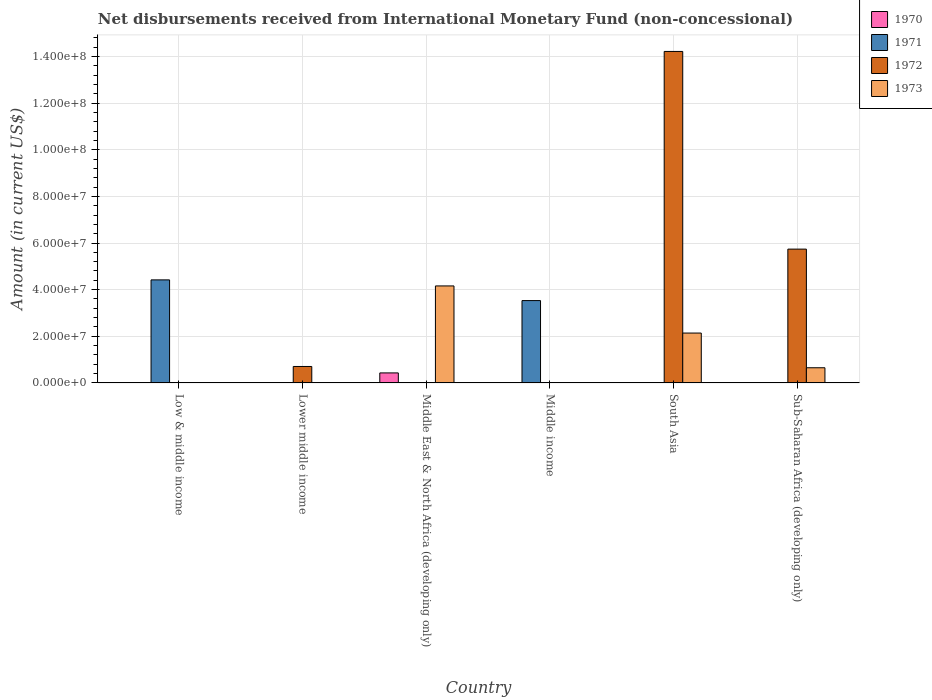Are the number of bars per tick equal to the number of legend labels?
Provide a short and direct response. No. What is the label of the 6th group of bars from the left?
Give a very brief answer. Sub-Saharan Africa (developing only). What is the amount of disbursements received from International Monetary Fund in 1971 in Lower middle income?
Provide a succinct answer. 0. Across all countries, what is the maximum amount of disbursements received from International Monetary Fund in 1973?
Offer a very short reply. 4.16e+07. What is the total amount of disbursements received from International Monetary Fund in 1970 in the graph?
Give a very brief answer. 4.30e+06. What is the difference between the amount of disbursements received from International Monetary Fund in 1971 in Low & middle income and that in Middle income?
Keep it short and to the point. 8.88e+06. What is the average amount of disbursements received from International Monetary Fund in 1970 per country?
Ensure brevity in your answer.  7.17e+05. What is the difference between the amount of disbursements received from International Monetary Fund of/in 1972 and amount of disbursements received from International Monetary Fund of/in 1973 in South Asia?
Your answer should be compact. 1.21e+08. What is the ratio of the amount of disbursements received from International Monetary Fund in 1971 in Low & middle income to that in Middle income?
Your response must be concise. 1.25. Is the amount of disbursements received from International Monetary Fund in 1973 in South Asia less than that in Sub-Saharan Africa (developing only)?
Offer a terse response. No. Is the difference between the amount of disbursements received from International Monetary Fund in 1972 in South Asia and Sub-Saharan Africa (developing only) greater than the difference between the amount of disbursements received from International Monetary Fund in 1973 in South Asia and Sub-Saharan Africa (developing only)?
Your response must be concise. Yes. What is the difference between the highest and the second highest amount of disbursements received from International Monetary Fund in 1973?
Ensure brevity in your answer.  3.51e+07. What is the difference between the highest and the lowest amount of disbursements received from International Monetary Fund in 1972?
Your response must be concise. 1.42e+08. In how many countries, is the amount of disbursements received from International Monetary Fund in 1971 greater than the average amount of disbursements received from International Monetary Fund in 1971 taken over all countries?
Ensure brevity in your answer.  2. Is it the case that in every country, the sum of the amount of disbursements received from International Monetary Fund in 1973 and amount of disbursements received from International Monetary Fund in 1970 is greater than the amount of disbursements received from International Monetary Fund in 1971?
Provide a succinct answer. No. How many bars are there?
Give a very brief answer. 9. Are all the bars in the graph horizontal?
Make the answer very short. No. What is the difference between two consecutive major ticks on the Y-axis?
Your answer should be compact. 2.00e+07. Does the graph contain any zero values?
Your response must be concise. Yes. Does the graph contain grids?
Provide a short and direct response. Yes. Where does the legend appear in the graph?
Your answer should be very brief. Top right. How many legend labels are there?
Your response must be concise. 4. How are the legend labels stacked?
Keep it short and to the point. Vertical. What is the title of the graph?
Offer a very short reply. Net disbursements received from International Monetary Fund (non-concessional). Does "1983" appear as one of the legend labels in the graph?
Keep it short and to the point. No. What is the Amount (in current US$) in 1971 in Low & middle income?
Your answer should be very brief. 4.42e+07. What is the Amount (in current US$) in 1972 in Low & middle income?
Your answer should be very brief. 0. What is the Amount (in current US$) of 1973 in Low & middle income?
Your response must be concise. 0. What is the Amount (in current US$) of 1970 in Lower middle income?
Ensure brevity in your answer.  0. What is the Amount (in current US$) of 1971 in Lower middle income?
Provide a short and direct response. 0. What is the Amount (in current US$) of 1972 in Lower middle income?
Your response must be concise. 7.06e+06. What is the Amount (in current US$) in 1973 in Lower middle income?
Your answer should be compact. 0. What is the Amount (in current US$) in 1970 in Middle East & North Africa (developing only)?
Offer a terse response. 4.30e+06. What is the Amount (in current US$) in 1973 in Middle East & North Africa (developing only)?
Your response must be concise. 4.16e+07. What is the Amount (in current US$) of 1970 in Middle income?
Offer a very short reply. 0. What is the Amount (in current US$) of 1971 in Middle income?
Your answer should be very brief. 3.53e+07. What is the Amount (in current US$) in 1972 in Middle income?
Make the answer very short. 0. What is the Amount (in current US$) of 1970 in South Asia?
Keep it short and to the point. 0. What is the Amount (in current US$) in 1971 in South Asia?
Provide a succinct answer. 0. What is the Amount (in current US$) in 1972 in South Asia?
Offer a terse response. 1.42e+08. What is the Amount (in current US$) in 1973 in South Asia?
Keep it short and to the point. 2.14e+07. What is the Amount (in current US$) of 1971 in Sub-Saharan Africa (developing only)?
Your response must be concise. 0. What is the Amount (in current US$) of 1972 in Sub-Saharan Africa (developing only)?
Make the answer very short. 5.74e+07. What is the Amount (in current US$) in 1973 in Sub-Saharan Africa (developing only)?
Ensure brevity in your answer.  6.51e+06. Across all countries, what is the maximum Amount (in current US$) of 1970?
Provide a succinct answer. 4.30e+06. Across all countries, what is the maximum Amount (in current US$) of 1971?
Provide a short and direct response. 4.42e+07. Across all countries, what is the maximum Amount (in current US$) in 1972?
Keep it short and to the point. 1.42e+08. Across all countries, what is the maximum Amount (in current US$) of 1973?
Keep it short and to the point. 4.16e+07. Across all countries, what is the minimum Amount (in current US$) in 1970?
Give a very brief answer. 0. Across all countries, what is the minimum Amount (in current US$) in 1971?
Offer a very short reply. 0. Across all countries, what is the minimum Amount (in current US$) in 1973?
Give a very brief answer. 0. What is the total Amount (in current US$) in 1970 in the graph?
Your answer should be compact. 4.30e+06. What is the total Amount (in current US$) in 1971 in the graph?
Give a very brief answer. 7.95e+07. What is the total Amount (in current US$) of 1972 in the graph?
Ensure brevity in your answer.  2.07e+08. What is the total Amount (in current US$) in 1973 in the graph?
Offer a terse response. 6.95e+07. What is the difference between the Amount (in current US$) in 1971 in Low & middle income and that in Middle income?
Your response must be concise. 8.88e+06. What is the difference between the Amount (in current US$) in 1972 in Lower middle income and that in South Asia?
Give a very brief answer. -1.35e+08. What is the difference between the Amount (in current US$) in 1972 in Lower middle income and that in Sub-Saharan Africa (developing only)?
Provide a succinct answer. -5.03e+07. What is the difference between the Amount (in current US$) of 1973 in Middle East & North Africa (developing only) and that in South Asia?
Provide a short and direct response. 2.02e+07. What is the difference between the Amount (in current US$) in 1973 in Middle East & North Africa (developing only) and that in Sub-Saharan Africa (developing only)?
Keep it short and to the point. 3.51e+07. What is the difference between the Amount (in current US$) in 1972 in South Asia and that in Sub-Saharan Africa (developing only)?
Ensure brevity in your answer.  8.48e+07. What is the difference between the Amount (in current US$) of 1973 in South Asia and that in Sub-Saharan Africa (developing only)?
Your answer should be very brief. 1.49e+07. What is the difference between the Amount (in current US$) in 1971 in Low & middle income and the Amount (in current US$) in 1972 in Lower middle income?
Offer a very short reply. 3.71e+07. What is the difference between the Amount (in current US$) in 1971 in Low & middle income and the Amount (in current US$) in 1973 in Middle East & North Africa (developing only)?
Your response must be concise. 2.60e+06. What is the difference between the Amount (in current US$) in 1971 in Low & middle income and the Amount (in current US$) in 1972 in South Asia?
Offer a terse response. -9.79e+07. What is the difference between the Amount (in current US$) of 1971 in Low & middle income and the Amount (in current US$) of 1973 in South Asia?
Your answer should be compact. 2.28e+07. What is the difference between the Amount (in current US$) of 1971 in Low & middle income and the Amount (in current US$) of 1972 in Sub-Saharan Africa (developing only)?
Your response must be concise. -1.32e+07. What is the difference between the Amount (in current US$) in 1971 in Low & middle income and the Amount (in current US$) in 1973 in Sub-Saharan Africa (developing only)?
Make the answer very short. 3.77e+07. What is the difference between the Amount (in current US$) of 1972 in Lower middle income and the Amount (in current US$) of 1973 in Middle East & North Africa (developing only)?
Keep it short and to the point. -3.45e+07. What is the difference between the Amount (in current US$) in 1972 in Lower middle income and the Amount (in current US$) in 1973 in South Asia?
Ensure brevity in your answer.  -1.43e+07. What is the difference between the Amount (in current US$) of 1972 in Lower middle income and the Amount (in current US$) of 1973 in Sub-Saharan Africa (developing only)?
Give a very brief answer. 5.46e+05. What is the difference between the Amount (in current US$) in 1970 in Middle East & North Africa (developing only) and the Amount (in current US$) in 1971 in Middle income?
Provide a short and direct response. -3.10e+07. What is the difference between the Amount (in current US$) in 1970 in Middle East & North Africa (developing only) and the Amount (in current US$) in 1972 in South Asia?
Your answer should be very brief. -1.38e+08. What is the difference between the Amount (in current US$) in 1970 in Middle East & North Africa (developing only) and the Amount (in current US$) in 1973 in South Asia?
Keep it short and to the point. -1.71e+07. What is the difference between the Amount (in current US$) of 1970 in Middle East & North Africa (developing only) and the Amount (in current US$) of 1972 in Sub-Saharan Africa (developing only)?
Ensure brevity in your answer.  -5.31e+07. What is the difference between the Amount (in current US$) of 1970 in Middle East & North Africa (developing only) and the Amount (in current US$) of 1973 in Sub-Saharan Africa (developing only)?
Ensure brevity in your answer.  -2.21e+06. What is the difference between the Amount (in current US$) in 1971 in Middle income and the Amount (in current US$) in 1972 in South Asia?
Offer a very short reply. -1.07e+08. What is the difference between the Amount (in current US$) of 1971 in Middle income and the Amount (in current US$) of 1973 in South Asia?
Keep it short and to the point. 1.39e+07. What is the difference between the Amount (in current US$) in 1971 in Middle income and the Amount (in current US$) in 1972 in Sub-Saharan Africa (developing only)?
Provide a succinct answer. -2.21e+07. What is the difference between the Amount (in current US$) of 1971 in Middle income and the Amount (in current US$) of 1973 in Sub-Saharan Africa (developing only)?
Your answer should be compact. 2.88e+07. What is the difference between the Amount (in current US$) of 1972 in South Asia and the Amount (in current US$) of 1973 in Sub-Saharan Africa (developing only)?
Offer a very short reply. 1.36e+08. What is the average Amount (in current US$) in 1970 per country?
Ensure brevity in your answer.  7.17e+05. What is the average Amount (in current US$) in 1971 per country?
Provide a short and direct response. 1.32e+07. What is the average Amount (in current US$) of 1972 per country?
Provide a succinct answer. 3.44e+07. What is the average Amount (in current US$) in 1973 per country?
Keep it short and to the point. 1.16e+07. What is the difference between the Amount (in current US$) of 1970 and Amount (in current US$) of 1973 in Middle East & North Africa (developing only)?
Make the answer very short. -3.73e+07. What is the difference between the Amount (in current US$) of 1972 and Amount (in current US$) of 1973 in South Asia?
Provide a succinct answer. 1.21e+08. What is the difference between the Amount (in current US$) in 1972 and Amount (in current US$) in 1973 in Sub-Saharan Africa (developing only)?
Your response must be concise. 5.09e+07. What is the ratio of the Amount (in current US$) in 1971 in Low & middle income to that in Middle income?
Provide a succinct answer. 1.25. What is the ratio of the Amount (in current US$) in 1972 in Lower middle income to that in South Asia?
Your response must be concise. 0.05. What is the ratio of the Amount (in current US$) of 1972 in Lower middle income to that in Sub-Saharan Africa (developing only)?
Your response must be concise. 0.12. What is the ratio of the Amount (in current US$) of 1973 in Middle East & North Africa (developing only) to that in South Asia?
Your response must be concise. 1.94. What is the ratio of the Amount (in current US$) of 1973 in Middle East & North Africa (developing only) to that in Sub-Saharan Africa (developing only)?
Give a very brief answer. 6.39. What is the ratio of the Amount (in current US$) of 1972 in South Asia to that in Sub-Saharan Africa (developing only)?
Provide a short and direct response. 2.48. What is the ratio of the Amount (in current US$) of 1973 in South Asia to that in Sub-Saharan Africa (developing only)?
Provide a succinct answer. 3.29. What is the difference between the highest and the second highest Amount (in current US$) of 1972?
Your answer should be compact. 8.48e+07. What is the difference between the highest and the second highest Amount (in current US$) in 1973?
Make the answer very short. 2.02e+07. What is the difference between the highest and the lowest Amount (in current US$) of 1970?
Your answer should be very brief. 4.30e+06. What is the difference between the highest and the lowest Amount (in current US$) of 1971?
Make the answer very short. 4.42e+07. What is the difference between the highest and the lowest Amount (in current US$) in 1972?
Make the answer very short. 1.42e+08. What is the difference between the highest and the lowest Amount (in current US$) in 1973?
Offer a terse response. 4.16e+07. 